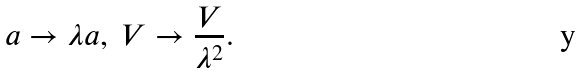<formula> <loc_0><loc_0><loc_500><loc_500>a \to \lambda a , \ V \to \frac { V } { \lambda ^ { 2 } } .</formula> 